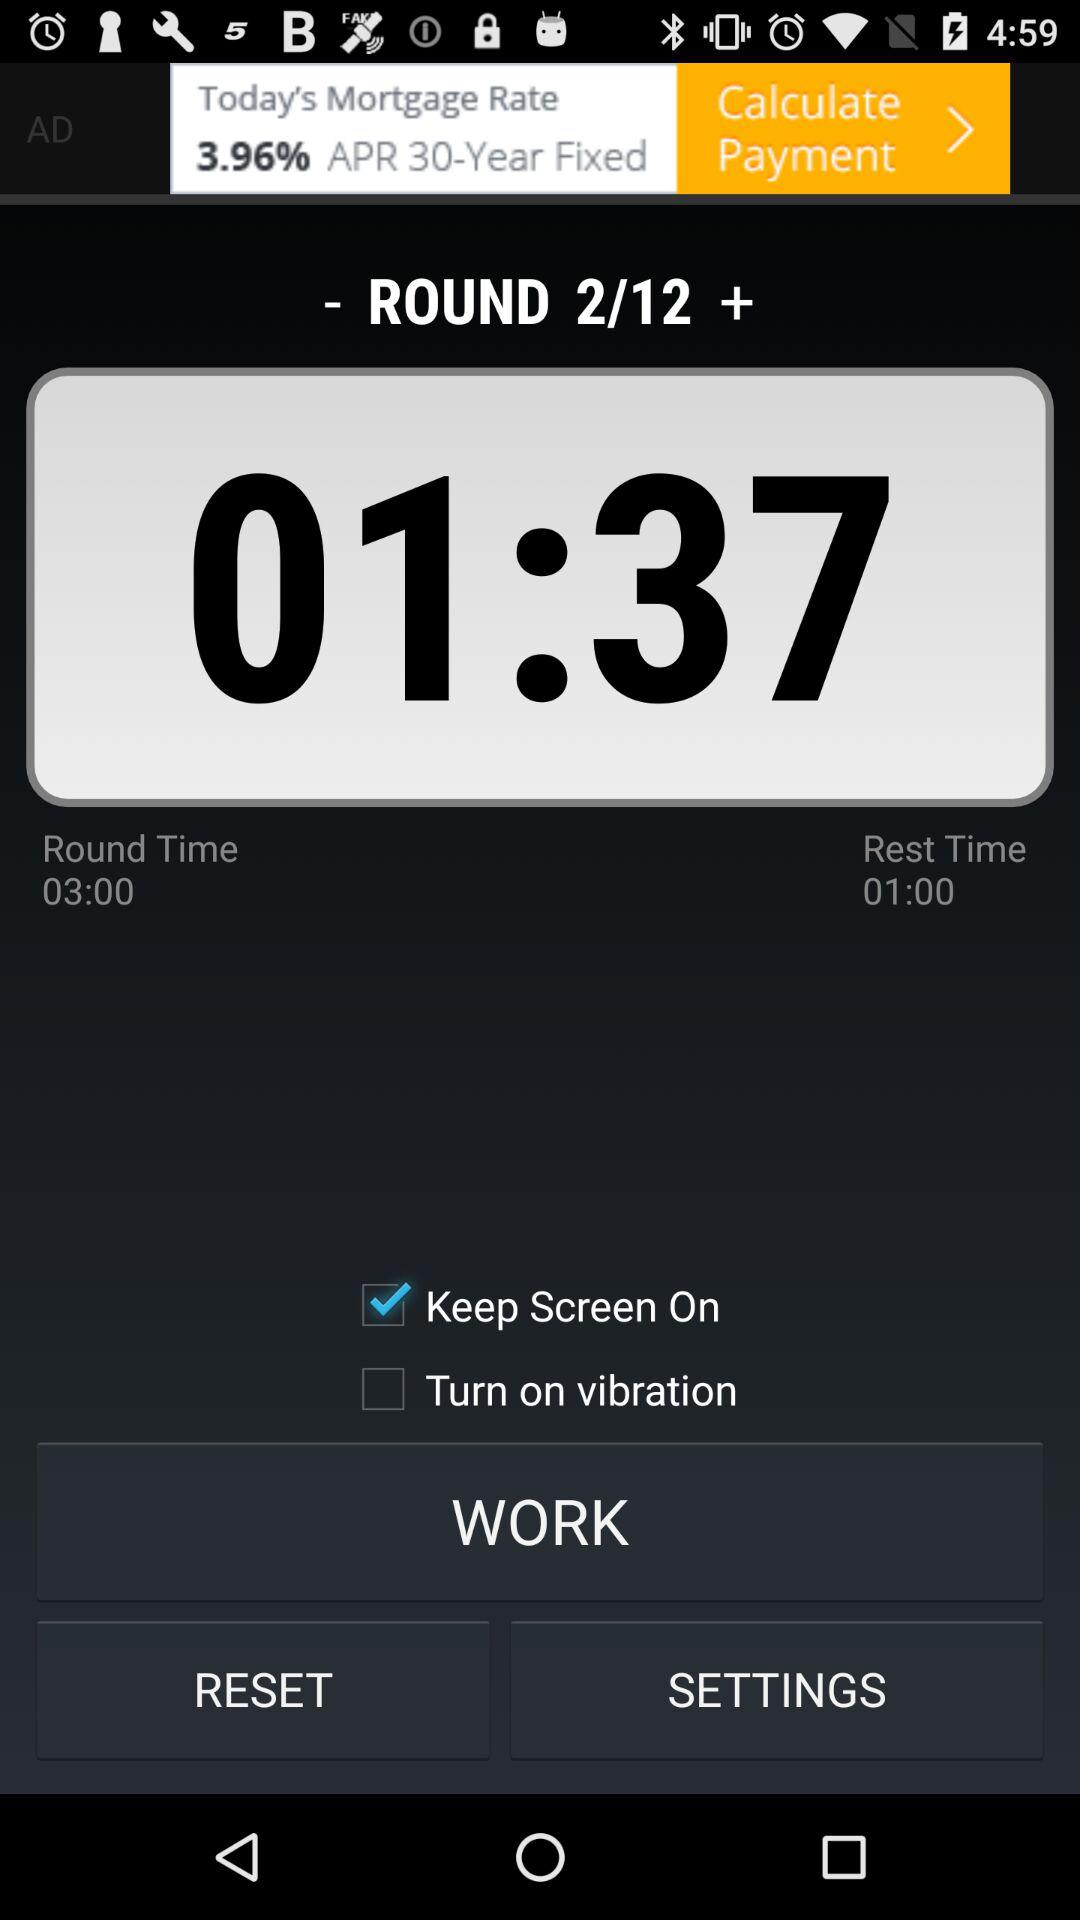Which round am I at? You are at round 2. 